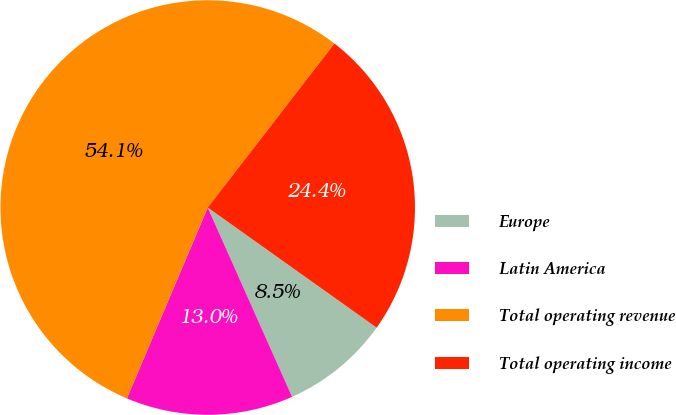Convert chart to OTSL. <chart><loc_0><loc_0><loc_500><loc_500><pie_chart><fcel>Europe<fcel>Latin America<fcel>Total operating revenue<fcel>Total operating income<nl><fcel>8.49%<fcel>13.05%<fcel>54.09%<fcel>24.37%<nl></chart> 